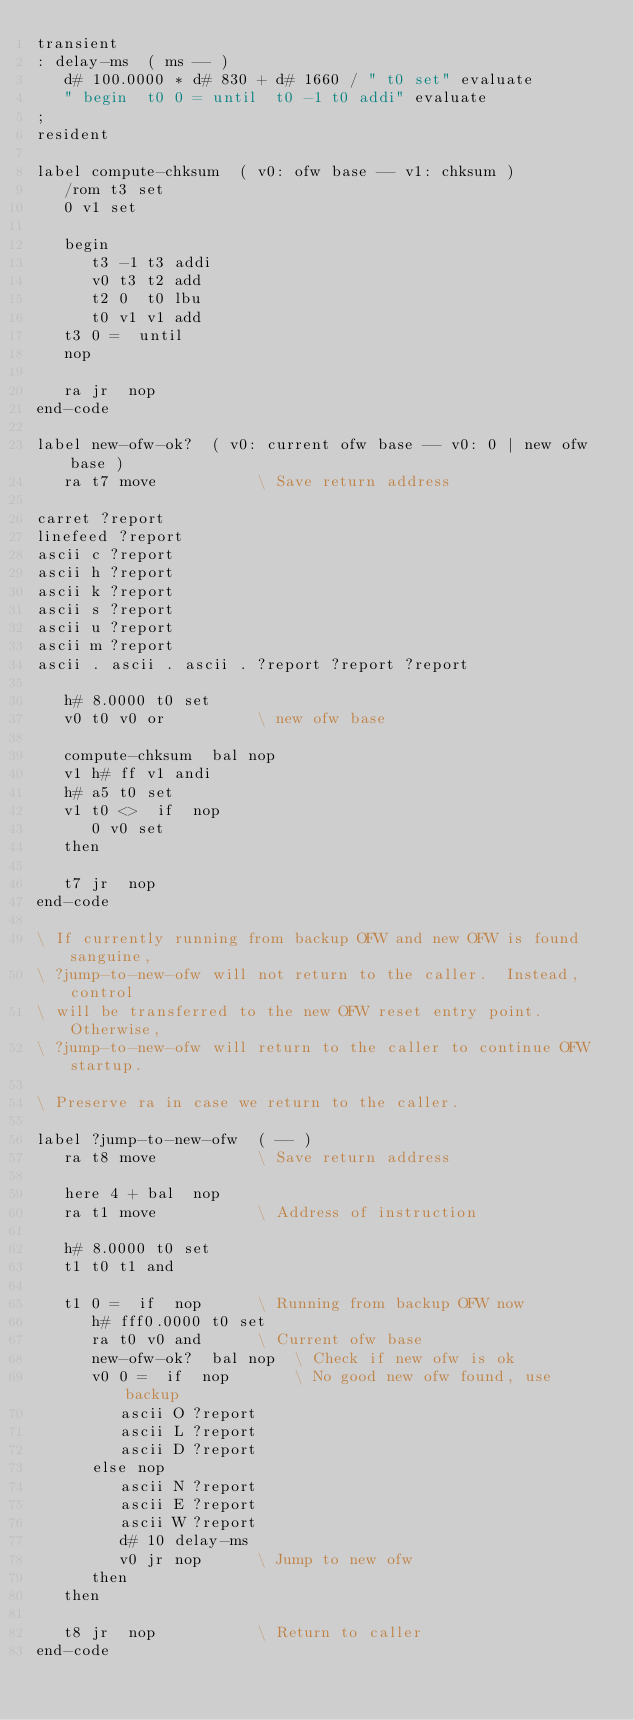<code> <loc_0><loc_0><loc_500><loc_500><_Forth_>transient
: delay-ms  ( ms -- )
   d# 100.0000 * d# 830 + d# 1660 / " t0 set" evaluate
   " begin  t0 0 = until  t0 -1 t0 addi" evaluate
;
resident

label compute-chksum  ( v0: ofw base -- v1: chksum )
   /rom t3 set
   0 v1 set

   begin
      t3 -1 t3 addi
      v0 t3 t2 add
      t2 0  t0 lbu
      t0 v1 v1 add
   t3 0 =  until
   nop

   ra jr  nop
end-code

label new-ofw-ok?  ( v0: current ofw base -- v0: 0 | new ofw base )
   ra t7 move			\ Save return address

carret ?report
linefeed ?report
ascii c ?report
ascii h ?report
ascii k ?report
ascii s ?report
ascii u ?report
ascii m ?report
ascii . ascii . ascii . ?report ?report ?report

   h# 8.0000 t0 set
   v0 t0 v0 or			\ new ofw base

   compute-chksum  bal nop
   v1 h# ff v1 andi
   h# a5 t0 set
   v1 t0 <>  if  nop  
      0 v0 set
   then

   t7 jr  nop
end-code

\ If currently running from backup OFW and new OFW is found sanguine,
\ ?jump-to-new-ofw will not return to the caller.  Instead, control
\ will be transferred to the new OFW reset entry point.  Otherwise,
\ ?jump-to-new-ofw will return to the caller to continue OFW startup.

\ Preserve ra in case we return to the caller.

label ?jump-to-new-ofw  ( -- )
   ra t8 move			\ Save return address

   here 4 + bal  nop
   ra t1 move			\ Address of instruction

   h# 8.0000 t0 set
   t1 t0 t1 and

   t1 0 =  if  nop		\ Running from backup OFW now
      h# fff0.0000 t0 set
      ra t0 v0 and		\ Current ofw base
      new-ofw-ok?  bal nop	\ Check if new ofw is ok
      v0 0 =  if  nop		\ No good new ofw found, use backup
         ascii O ?report
         ascii L ?report
         ascii D ?report
      else nop
         ascii N ?report
         ascii E ?report
         ascii W ?report
         d# 10 delay-ms
         v0 jr nop		\ Jump to new ofw
      then
   then

   t8 jr  nop			\ Return to caller
end-code

</code> 